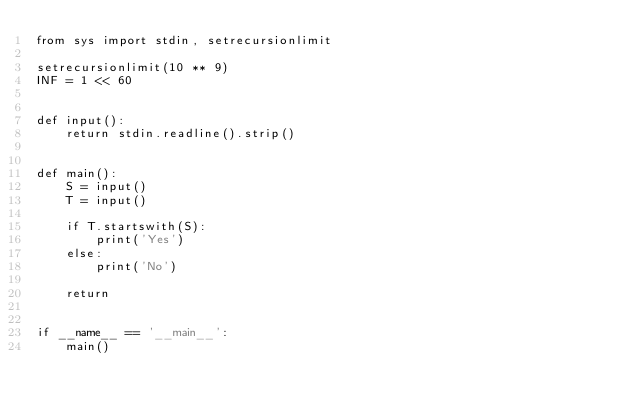Convert code to text. <code><loc_0><loc_0><loc_500><loc_500><_Python_>from sys import stdin, setrecursionlimit

setrecursionlimit(10 ** 9)
INF = 1 << 60


def input():
    return stdin.readline().strip()


def main():
    S = input()
    T = input()

    if T.startswith(S):
        print('Yes')
    else:
        print('No')

    return


if __name__ == '__main__':
    main()
</code> 